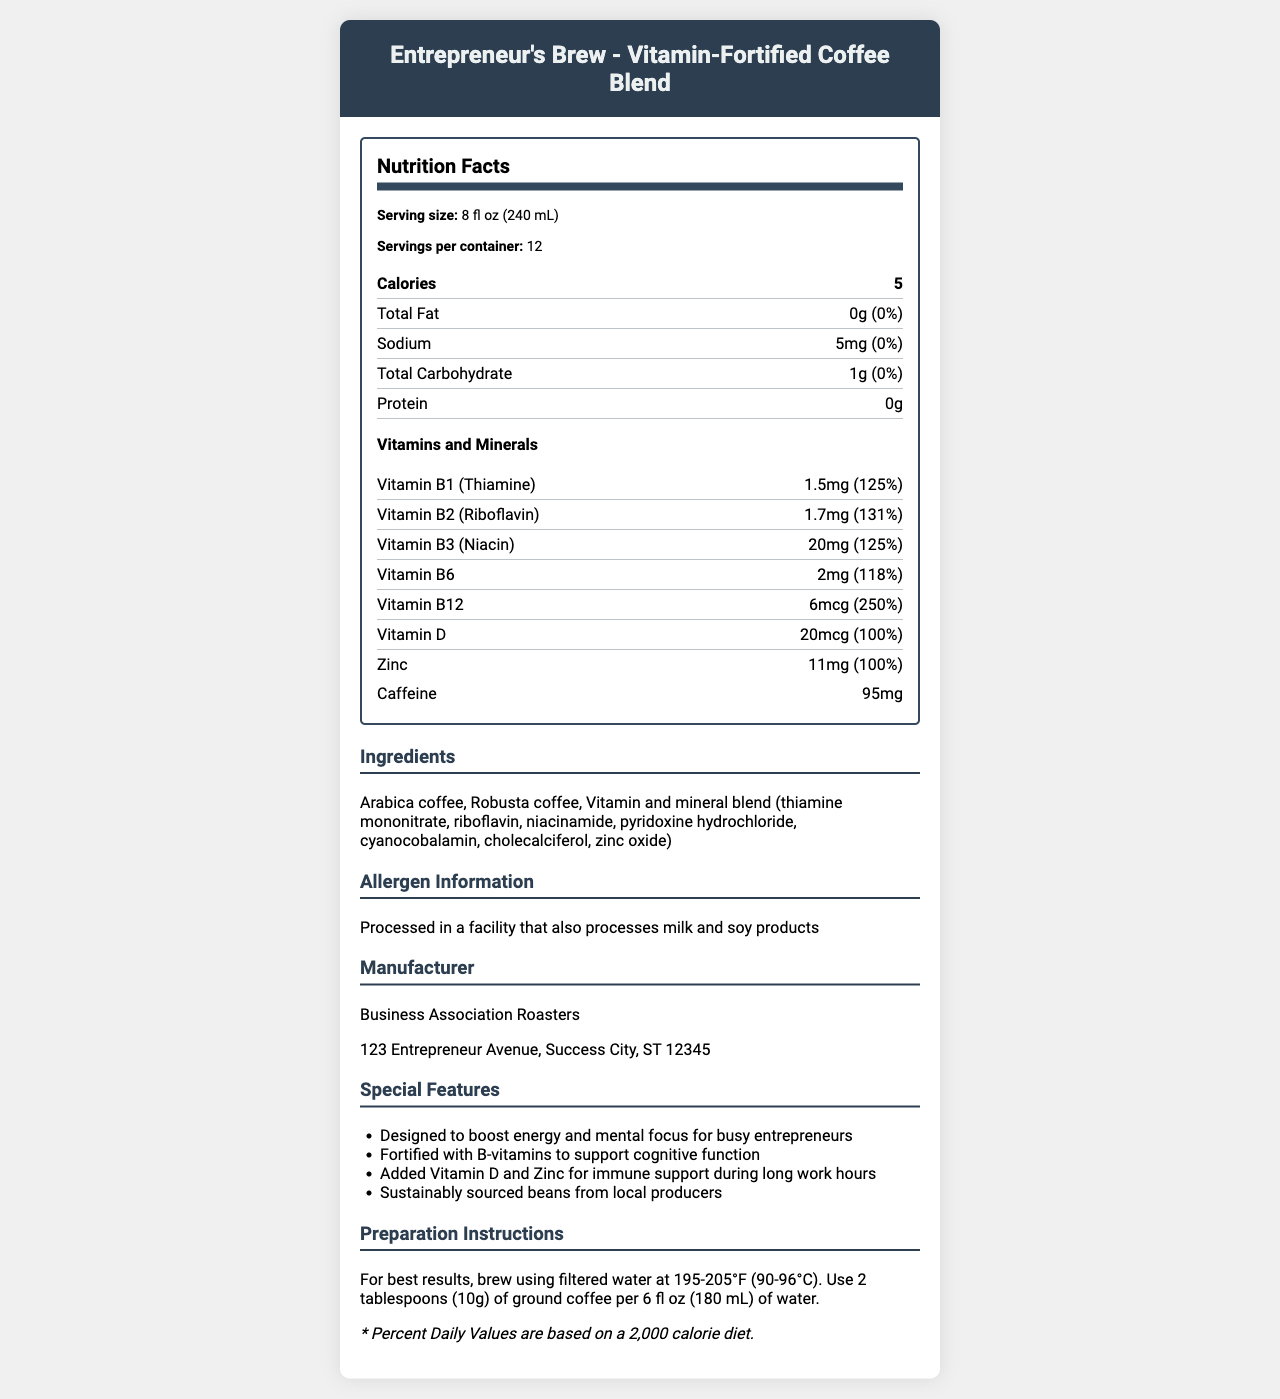what is the serving size? The serving size is mentioned at the top of the Nutrition Facts section in the document.
Answer: 8 fl oz (240 mL) how many servings are there per container? The document indicates there are 12 servings per container in the Serving Info section.
Answer: 12 what is the amount of calories per serving? The Calories section of the Nutrition Facts states there are 5 calories per serving.
Answer: 5 how much sodium does one serving contain? According to the Sodium section in the Nutrition Facts, one serving contains 5mg of sodium.
Answer: 5mg how much caffeine is in a serving? The Caffeine section at the bottom of the Nutrition Facts indicates 95mg of caffeine per serving.
Answer: 95mg which vitamin has the highest daily value percentage in the coffee blend? A. Vitamin D B. Vitamin B1 (Thiamine) C. Vitamin B12 Vitamin B12 has a Daily Value percentage of 250%, which is the highest among the listed vitamins.
Answer: C what is the main source of protein in the coffee blend? A. Arabica coffee B. Robusta coffee C. There is no protein in the coffee blend The document shows that the protein content is 0g, meaning there is no protein in the coffee blend.
Answer: C does the coffee contain any allergens? The Allergen Information section states that it is processed in a facility that also processes milk and soy products, indicating the potential presence of these allergens.
Answer: Yes what is the calorie percentage of daily value based on a 2,000 calorie diet? This information is provided in the disclaimer at the bottom of the document.
Answer: * Percent Daily Values are based on a 2,000 calorie diet. summarize the key features of the document. The document is structured to provide both precise nutritional data and supplementary context about the product’s health benefits and manufacturing details, ensuring comprehensive understanding for consumers.
Answer: The document provides detailed Nutrition Facts for "Entrepreneur's Brew - Vitamin-Fortified Coffee Blend," including serving size, calories, and nutrient content. It highlights the high daily values of B-vitamins and other vitamins and minerals, as well as the caffeine content. Additionally, it identifies the ingredients, allergen information, special features supporting energy, cognitive function, and immune support, and preparation instructions. what is the address of the manufacturer? This information is provided under the Manufacturer section in the document.
Answer: 123 Entrepreneur Avenue, Success City, ST 12345 how much Vitamin D is in a serving and its daily value percentage? The Vitamins and Minerals section under Nutrition Facts lists Vitamin D as containing 20mcg, accounting for 100% of the daily value.
Answer: 20mcg, 100% how many grams of total fat are there per serving? According to the Total Fat section in the Nutrition Facts, each serving contains 0g of total fat.
Answer: 0g what are the specific ingredients in the vitamin and mineral blend? The Ingredients section lists the components of the vitamin and mineral blend used in the coffee.
Answer: thiamine mononitrate, riboflavin, niacinamide, pyridoxine hydrochloride, cyanocobalamin, cholecalciferol, zinc oxide does the document mention any health benefits related to the coffee blend? The Special Features section mentions benefits such as boosting energy, supporting cognitive function, immune support, and sustainably sourced beans.
Answer: Yes which vitamins listed in the document have a daily value percentage greater than or equal to 125%? These vitamins have daily value percentages of 125% or more according to the Vitamins and Minerals section.
Answer: Vitamin B1 (Thiamine), Vitamin B2 (Riboflavin), Vitamin B3 (Niacin), Vitamin B12 what are the preparation instructions for the coffee blend? The Preparation Instructions section provides these details.
Answer: Brew using filtered water at 195-205°F (90-96°C). Use 2 tablespoons (10g) of ground coffee per 6 fl oz (180 mL) of water. what percentage of the daily value of sodium does a serving provide? The Sodium section in the Nutrition Facts shows that a serving provides 0% of the daily value of sodium.
Answer: 0% how much total carbohydrate is in one serving? The Total Carbohydrate section in the Nutrition Facts states that each serving contains 1g of total carbohydrate.
Answer: 1g when was the coffee blend first manufactured? The document does not provide information about the manufacturing date of the coffee blend.
Answer: Not enough information 